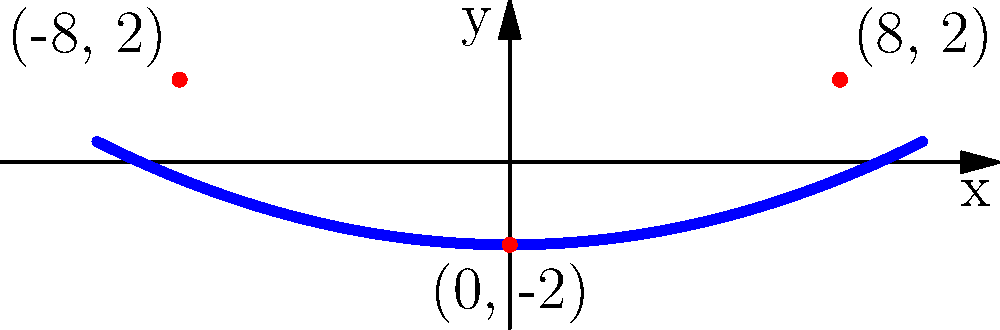For an abstract stage backdrop, you need to create a parabolic arch. The arch passes through the points $(-8, 2)$, $(0, -2)$, and $(8, 2)$. Find the equation of this parabola in the form $y = ax^2 + bx + c$. To find the equation of the parabola, we'll follow these steps:

1) The general form of a parabola is $y = ax^2 + bx + c$.

2) We know the parabola passes through three points: $(-8, 2)$, $(0, -2)$, and $(8, 2)$.

3) The vertex of the parabola is at $(0, -2)$, which means $b = 0$ and $c = -2$.

4) Our equation is now $y = ax^2 - 2$.

5) We can use either $(-8, 2)$ or $(8, 2)$ to find $a$. Let's use $(8, 2)$:

   $2 = a(8^2) - 2$
   $4 = 64a$
   $a = \frac{1}{16} = 0.0625$

6) Therefore, the equation of the parabola is:

   $y = 0.0625x^2 - 2$

   or in fraction form:
   
   $y = \frac{1}{16}x^2 - 2$
Answer: $y = \frac{1}{16}x^2 - 2$ 